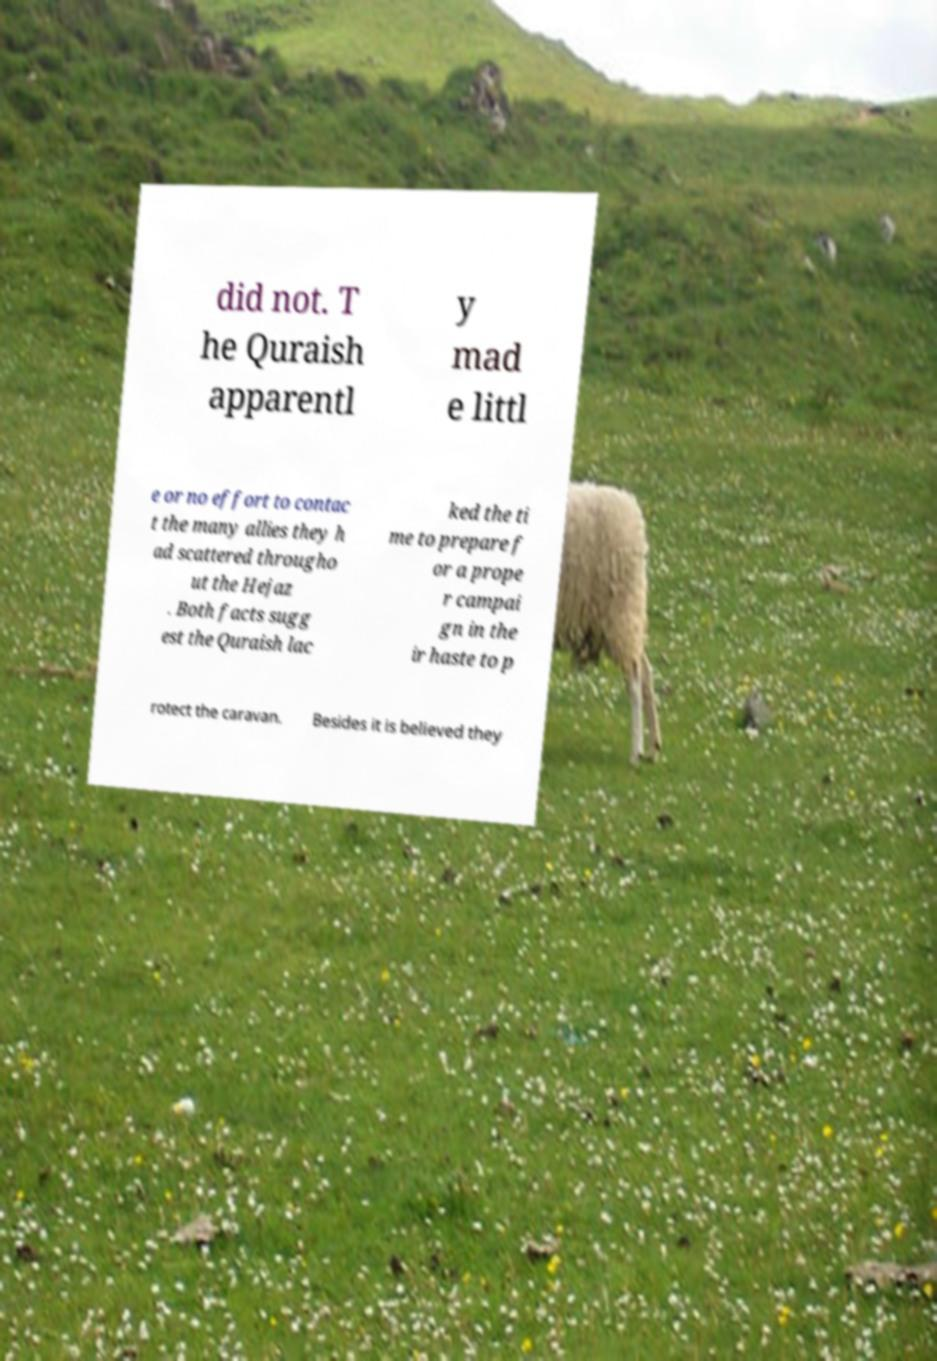What messages or text are displayed in this image? I need them in a readable, typed format. did not. T he Quraish apparentl y mad e littl e or no effort to contac t the many allies they h ad scattered througho ut the Hejaz . Both facts sugg est the Quraish lac ked the ti me to prepare f or a prope r campai gn in the ir haste to p rotect the caravan. Besides it is believed they 